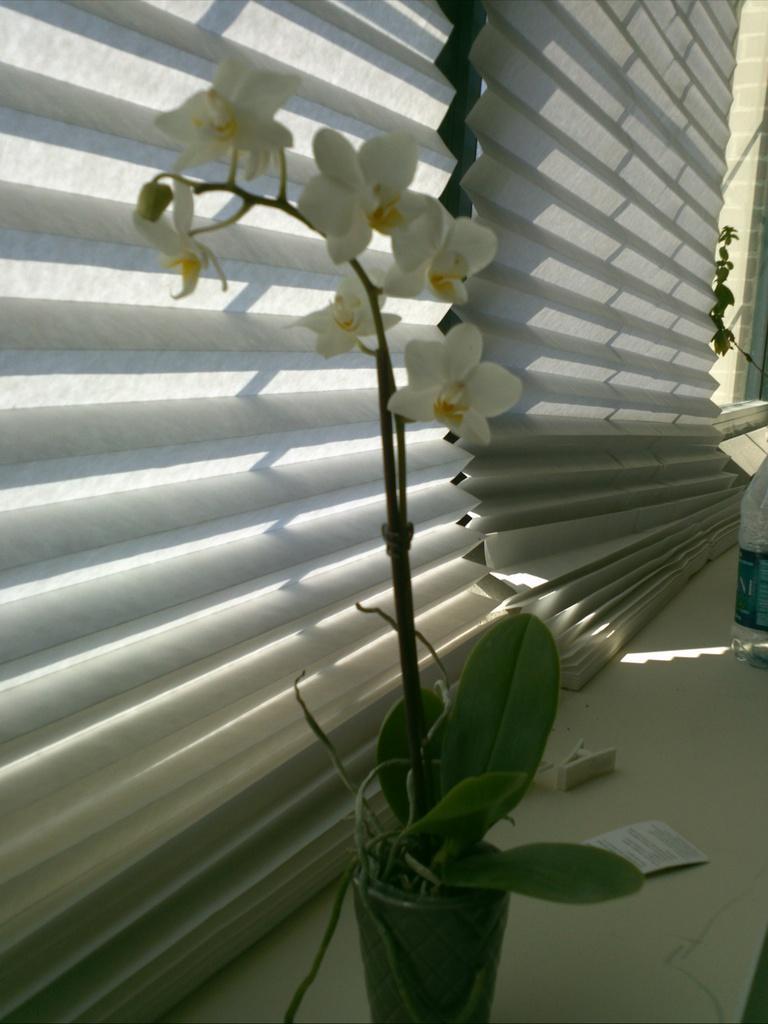How would you summarize this image in a sentence or two? In the image in the center, we can see plant pots and flowers, which are in yellow and white color. In the background there is a wall and window blinds. 